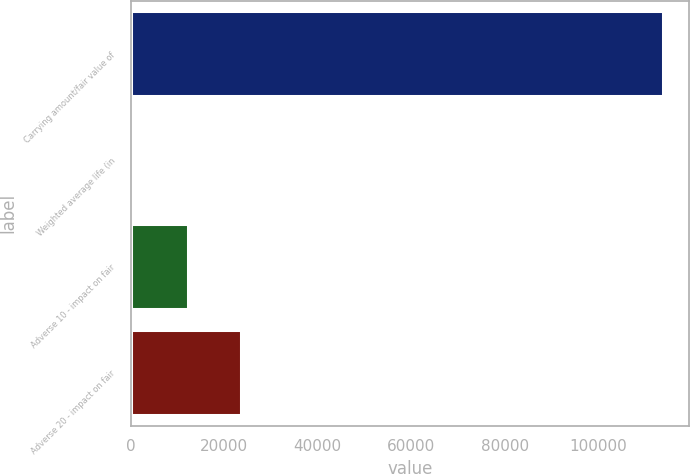<chart> <loc_0><loc_0><loc_500><loc_500><bar_chart><fcel>Carrying amount/fair value of<fcel>Weighted average life (in<fcel>Adverse 10 - impact on fair<fcel>Adverse 20 - impact on fair<nl><fcel>113821<fcel>1.2<fcel>12239<fcel>23621<nl></chart> 